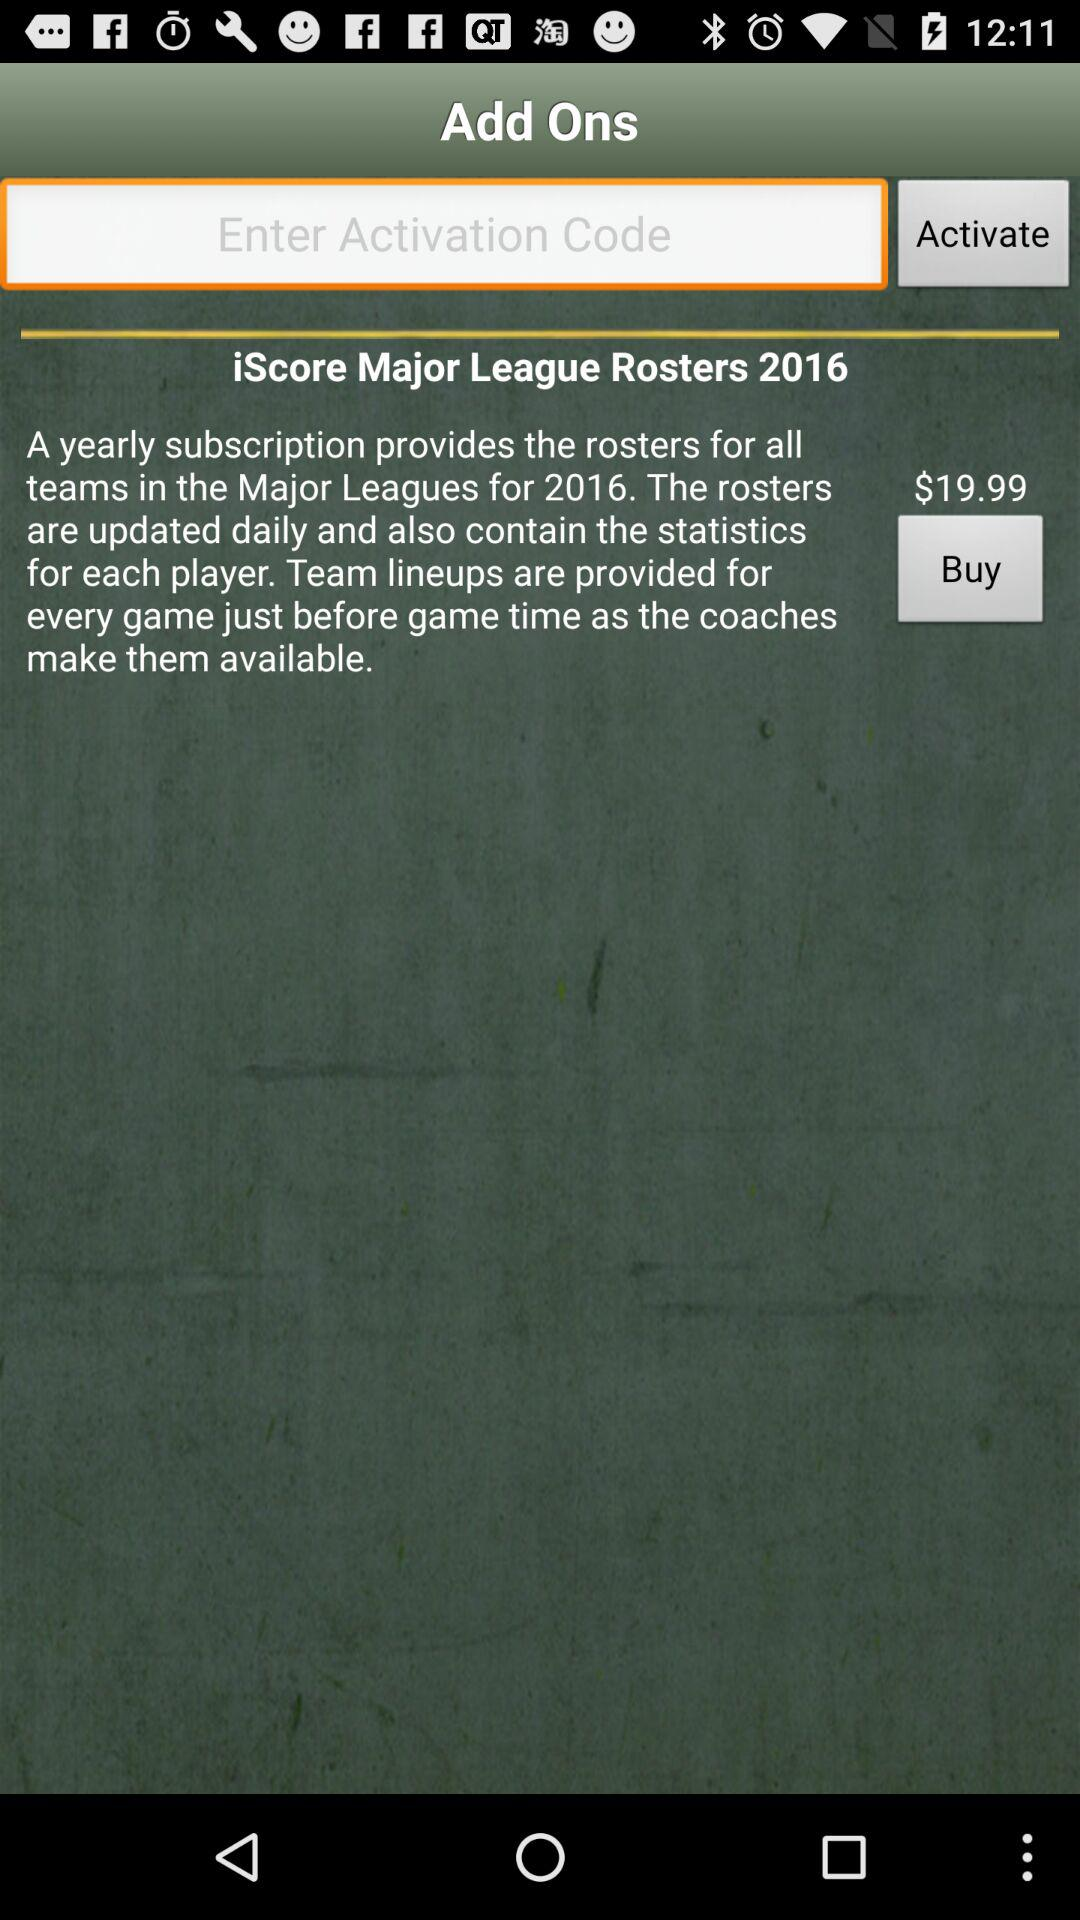What's the yearly subscription price for "iScore Major League Rosters 2016"? The yearly subscription price is $19.99. 